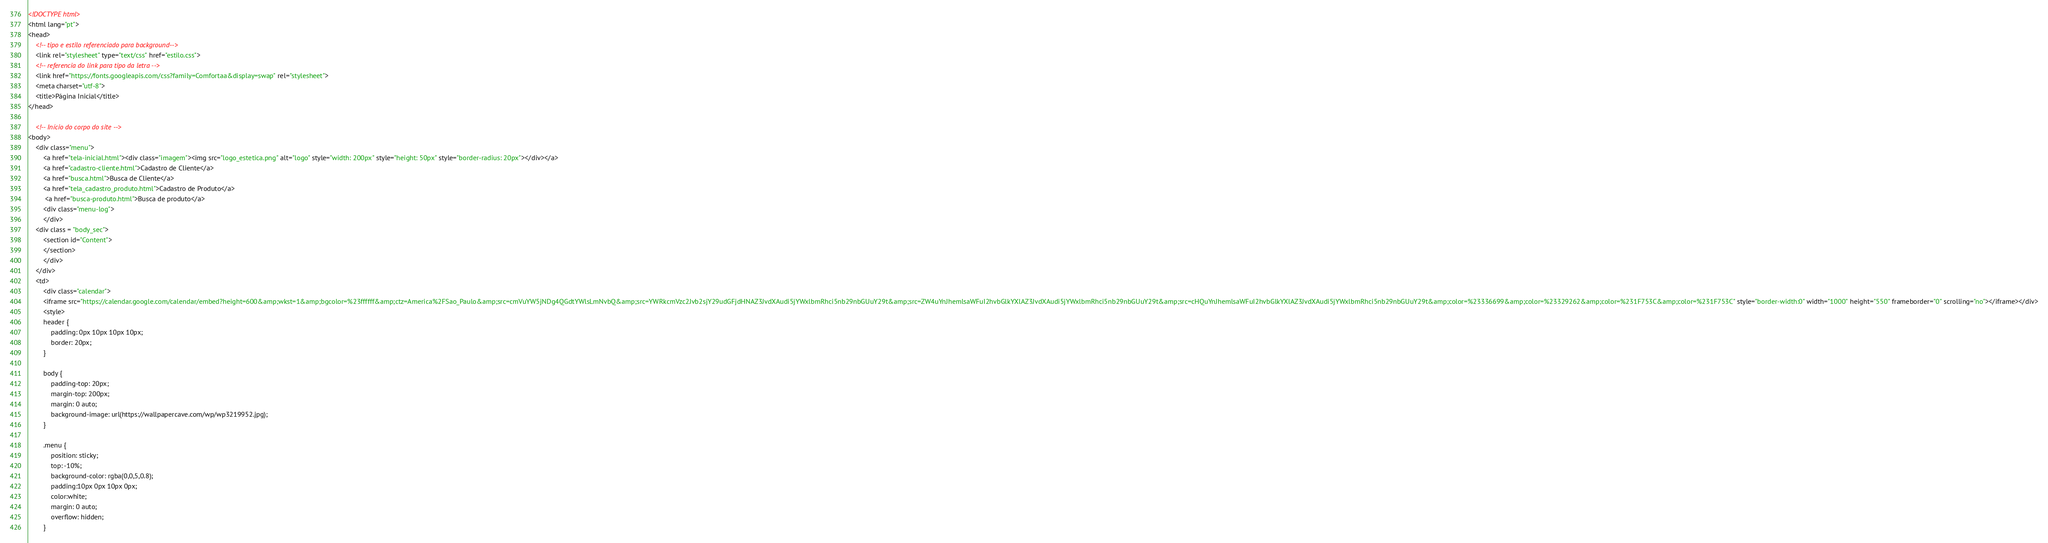Convert code to text. <code><loc_0><loc_0><loc_500><loc_500><_HTML_><!DOCTYPE html> 
<html lang="pt"> 
<head>
    <!-- tipo e estilo referenciado para background-->
    <link rel="stylesheet" type="text/css" href="estilo.css">
    <!-- referencia do link para tipo da letra -->
    <link href="https://fonts.googleapis.com/css?family=Comfortaa&display=swap" rel="stylesheet">
    <meta charset="utf-8">
    <title>Página Inicial</title> 
</head> 

    <!-- Início do corpo do site -->
<body> 
    <div class="menu"> 
        <a href="tela-inicial.html"><div class="imagem"><img src="logo_estetica.png" alt="logo" style="width: 200px" style="height: 50px" style="border-radius: 20px"></div></a>
        <a href="cadastro-cliente.html">Cadastro de Cliente</a> 
        <a href="busca.html">Busca de Cliente</a> 
        <a href="tela_cadastro_produto.html">Cadastro de Produto</a> 
         <a href="busca-produto.html">Busca de produto</a> 
        <div class="menu-log"> 
        </div> 
    <div class = "body_sec"> 
        <section id="Content"> 
        </section> 
        </div>
    </div>
    <td>
        <div class="calendar">
        <iframe src="https://calendar.google.com/calendar/embed?height=600&amp;wkst=1&amp;bgcolor=%23ffffff&amp;ctz=America%2FSao_Paulo&amp;src=cmVuYW5jNDg4QGdtYWlsLmNvbQ&amp;src=YWRkcmVzc2Jvb2sjY29udGFjdHNAZ3JvdXAudi5jYWxlbmRhci5nb29nbGUuY29t&amp;src=ZW4uYnJhemlsaWFuI2hvbGlkYXlAZ3JvdXAudi5jYWxlbmRhci5nb29nbGUuY29t&amp;src=cHQuYnJhemlsaWFuI2hvbGlkYXlAZ3JvdXAudi5jYWxlbmRhci5nb29nbGUuY29t&amp;color=%23336699&amp;color=%23329262&amp;color=%231F753C&amp;color=%231F753C" style="border-width:0" width="1000" height="550" frameborder="0" scrolling="no"></iframe></div>
        <style>
        header {
            padding: 0px 10px 10px 10px;
            border: 20px;
        }
        
        body { 
            padding-top: 20px;
            margin-top: 200px;
            margin: 0 auto; 
            background-image: url(https://wallpapercave.com/wp/wp3219952.jpg);
        } 
      
        .menu {  
            position: sticky; 
            top: -10%; 
            background-color: rgba(0,0,5,0.8); 
            padding:10px 0px 10px 0px;
            color:white; 
            margin: 0 auto; 
            overflow: hidden; 
        } </code> 